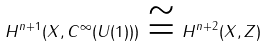Convert formula to latex. <formula><loc_0><loc_0><loc_500><loc_500>H ^ { n + 1 } ( X , C ^ { \infty } ( U ( 1 ) ) ) \, \cong \, H ^ { n + 2 } ( X , { Z } )</formula> 